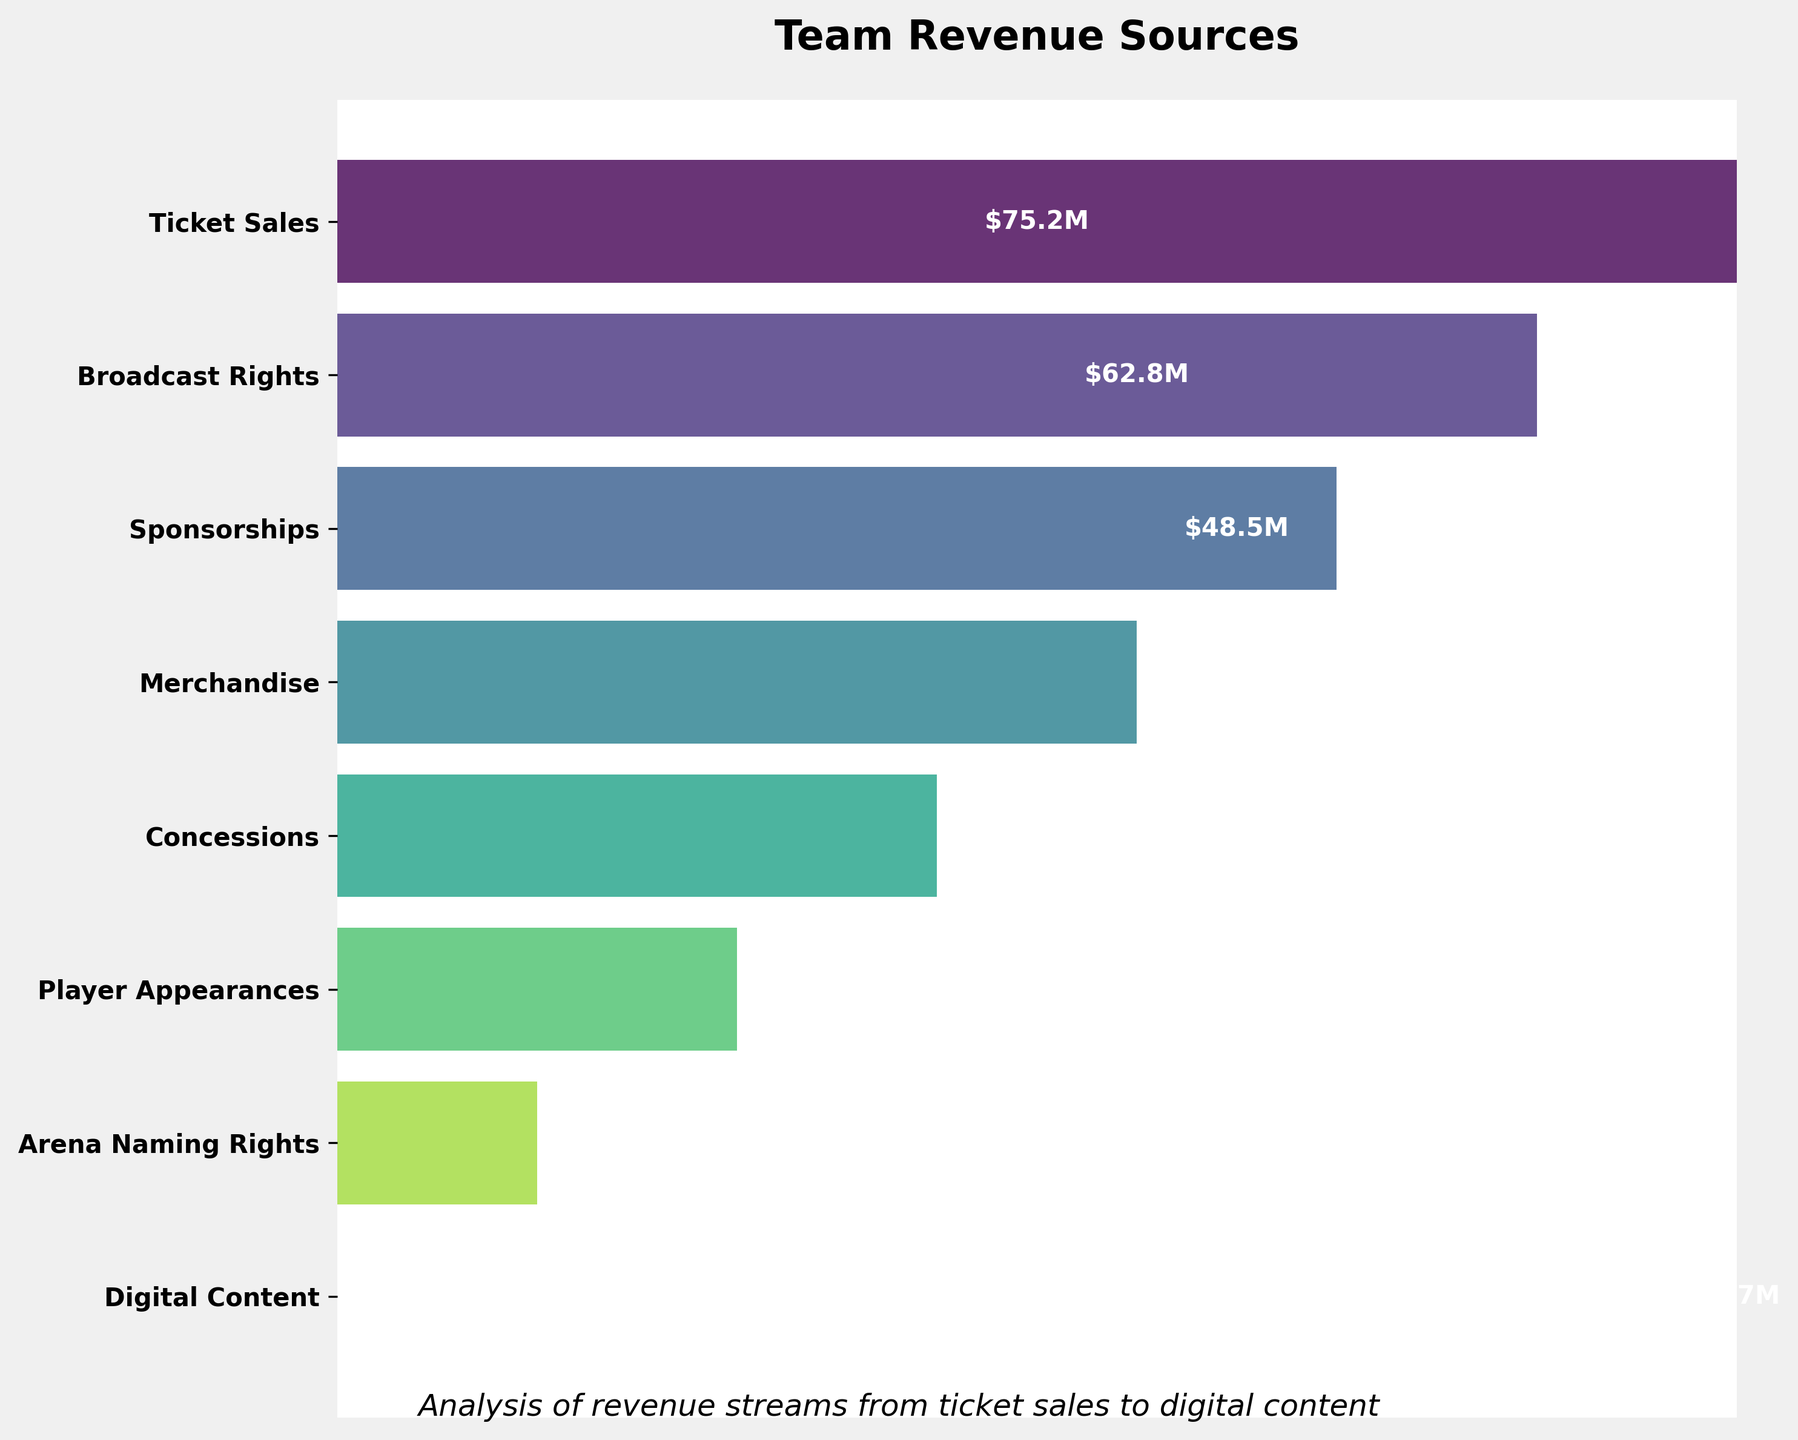What is the highest revenue source according to the figure? The highest revenue source is visually located at the top of the funnel chart and has the largest width. It is labeled as 'Ticket Sales' with a revenue value of $75.2M.
Answer: Ticket Sales What revenue stream follows 'Broadcast Rights' in the chart? To identify the next revenue stream, look at the stage immediately below 'Broadcast Rights' in the funnel chart. The stage following 'Broadcast Rights' is labeled 'Sponsorships' with $48.5M.
Answer: Sponsorships How many revenue streams are displayed in the funnel chart? Count the number of unique stages listed along the y-axis of the funnel chart. There are 8 revenue streams displayed: Ticket Sales, Broadcast Rights, Sponsorships, Merchandise, Concessions, Player Appearances, Arena Naming Rights, Digital Content.
Answer: 8 Which revenue source contributes less than $20M according to the figure? Look at the values on the funnel chart and identify the stages with revenue less than $20M: 'Player Appearances' ($15.6M), 'Arena Naming Rights' ($12.1M), and 'Digital Content' ($8.7M).
Answer: Player Appearances, Arena Naming Rights, Digital Content What is the combined revenue of 'Merchandise' and 'Concessions' stages? To find the combined revenue, sum the values of 'Merchandise' ($36.9M) and 'Concessions' ($22.3M). So, $36.9M + $22.3M = $59.2M.
Answer: $59.2M What stage has the smallest width in the funnel chart? The width decreases as we move down the funnel. The last stage at the bottom has the smallest width, which is 'Digital Content' with $8.7M in revenue.
Answer: Digital Content Which revenue source contributes more: 'Player Appearances' or 'Arena Naming Rights'? Compare the values of 'Player Appearances' ($15.6M) and 'Arena Naming Rights' ($12.1M). 'Player Appearances' has a higher revenue.
Answer: Player Appearances What's the difference in revenue between 'Ticket Sales' and 'Broadcast Rights'? The revenues are $75.2M for 'Ticket Sales' and $62.8M for 'Broadcast Rights'. The difference is $75.2M - $62.8M = $12.4M.
Answer: $12.4M 